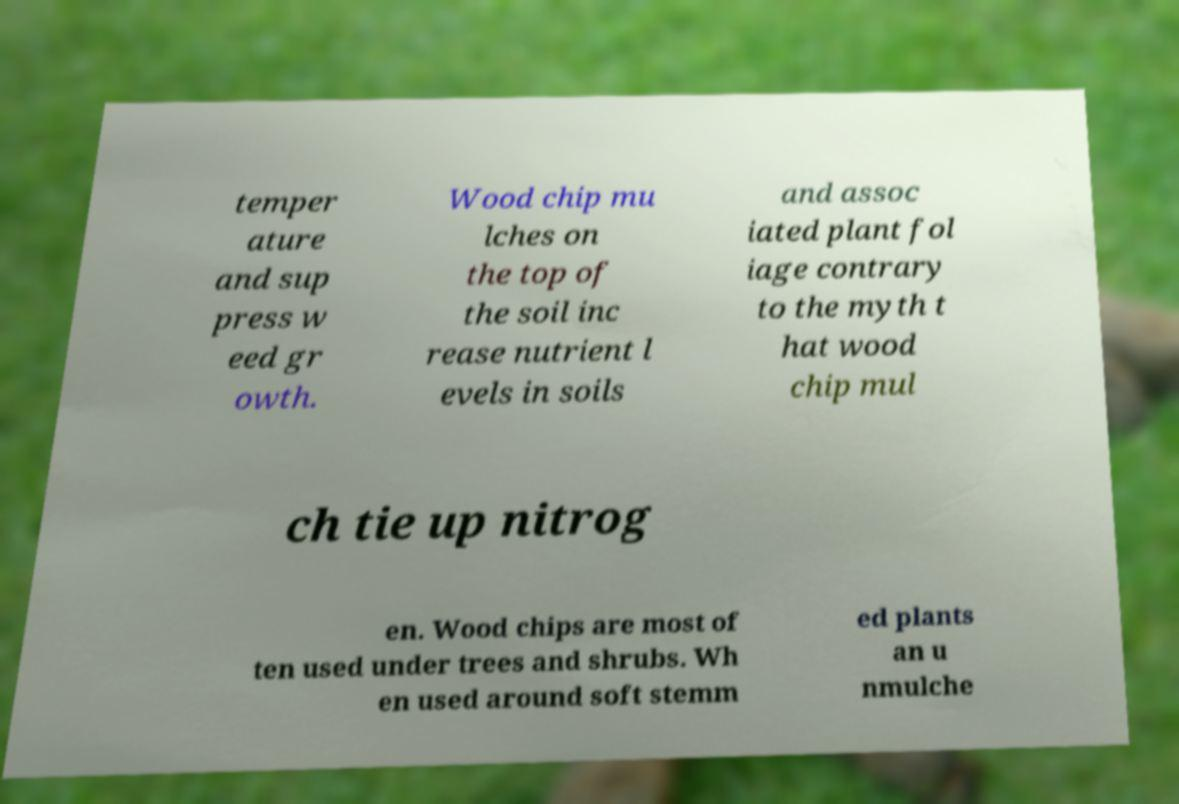There's text embedded in this image that I need extracted. Can you transcribe it verbatim? temper ature and sup press w eed gr owth. Wood chip mu lches on the top of the soil inc rease nutrient l evels in soils and assoc iated plant fol iage contrary to the myth t hat wood chip mul ch tie up nitrog en. Wood chips are most of ten used under trees and shrubs. Wh en used around soft stemm ed plants an u nmulche 